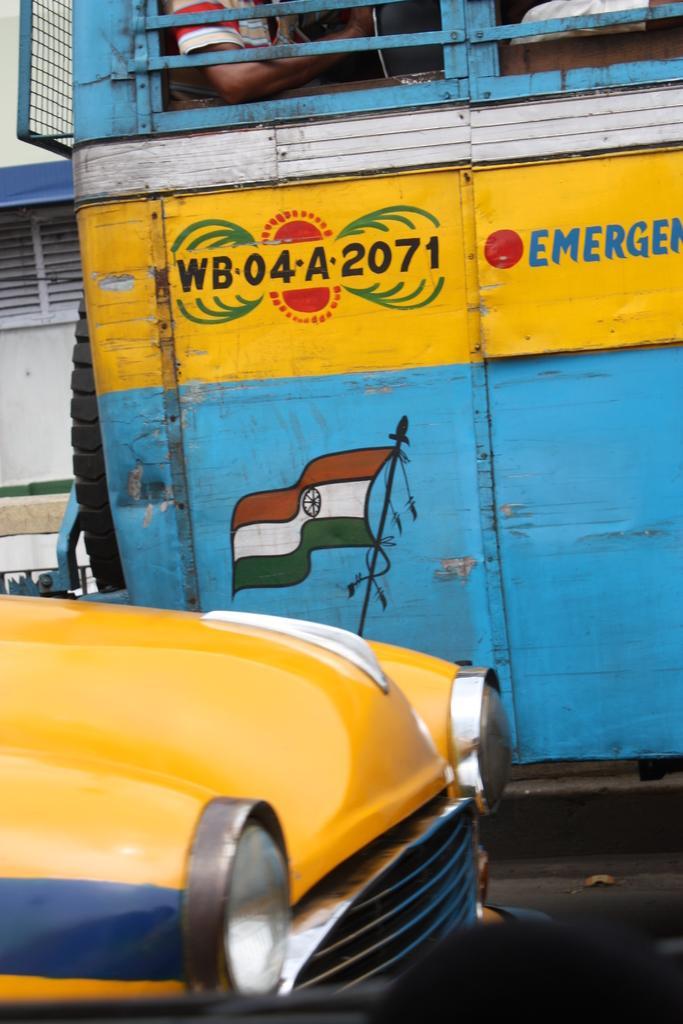Describe this image in one or two sentences. In this picture we can see a car on the left side. There is some text, flag and a few people are visible in the bus. We can see a building in the background. 